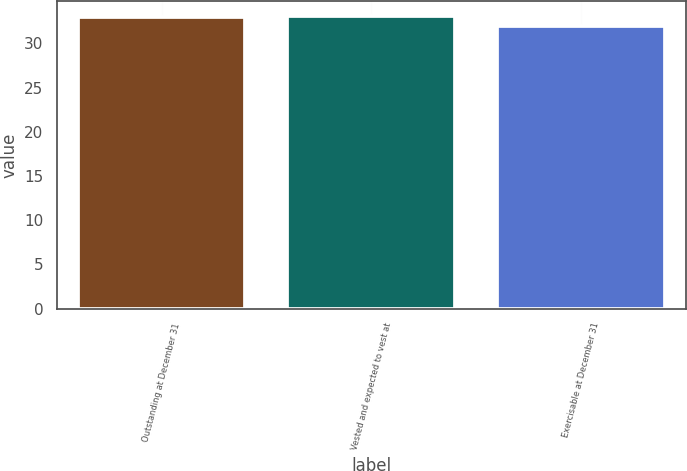Convert chart to OTSL. <chart><loc_0><loc_0><loc_500><loc_500><bar_chart><fcel>Outstanding at December 31<fcel>Vested and expected to vest at<fcel>Exercisable at December 31<nl><fcel>33<fcel>33.1<fcel>32<nl></chart> 